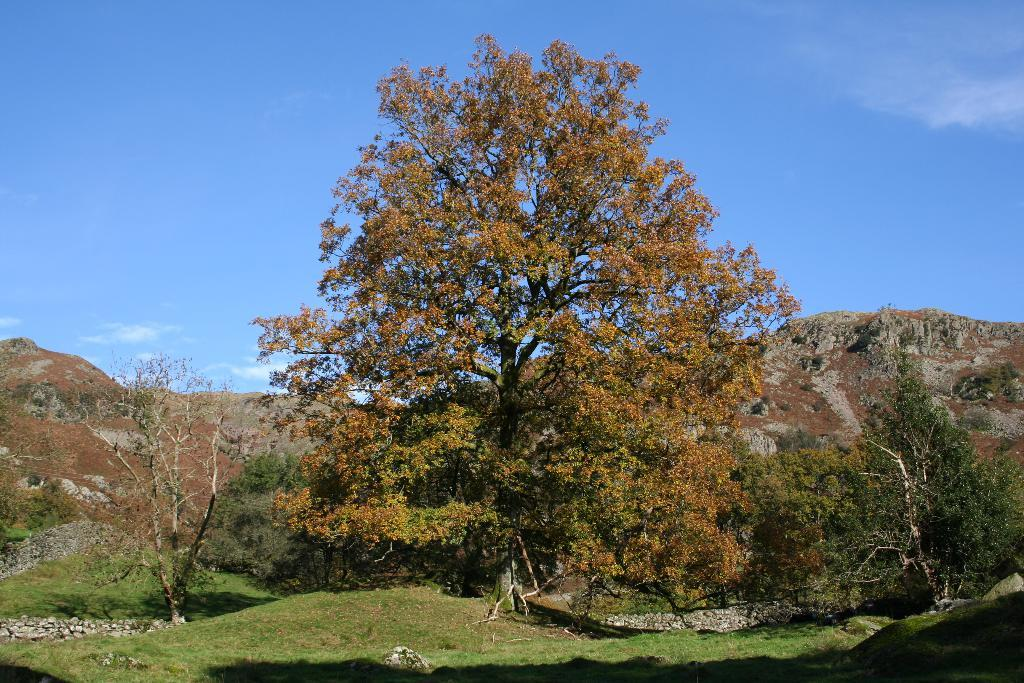What type of vegetation can be seen in the image? There are trees in the image. What is on the ground in the image? There is grass on the ground in the image. What can be seen in the distance in the image? There are mountains in the background of the image. What is visible at the top of the image? The sky is visible at the top of the image. How many ants are crawling on the flower in the image? There are no ants or flowers present in the image. What color is the sweater worn by the person in the image? There is no person or sweater present in the image. 